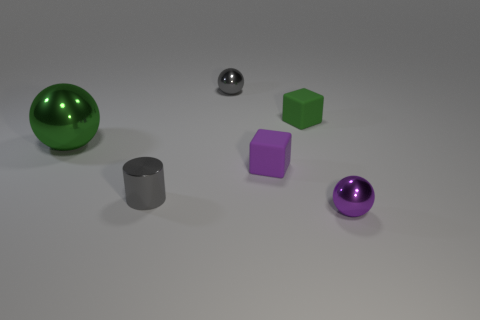How many other objects are there of the same size as the purple shiny sphere?
Provide a short and direct response. 4. Are the small sphere that is behind the purple metallic object and the purple thing behind the small metal cylinder made of the same material?
Your response must be concise. No. There is a shiny ball on the right side of the tiny matte object in front of the green shiny object; what size is it?
Give a very brief answer. Small. Is there a matte thing that has the same color as the big metal ball?
Make the answer very short. Yes. There is a small metal sphere that is to the left of the tiny purple metallic ball; is it the same color as the tiny metal object that is left of the small gray metal ball?
Give a very brief answer. Yes. What is the shape of the green shiny thing?
Your answer should be compact. Sphere. There is a cylinder; what number of balls are to the right of it?
Offer a very short reply. 2. What number of brown cubes have the same material as the tiny purple ball?
Your response must be concise. 0. Is the material of the tiny block that is in front of the big green shiny ball the same as the tiny purple sphere?
Your answer should be compact. No. Are there any purple shiny objects?
Your response must be concise. Yes. 